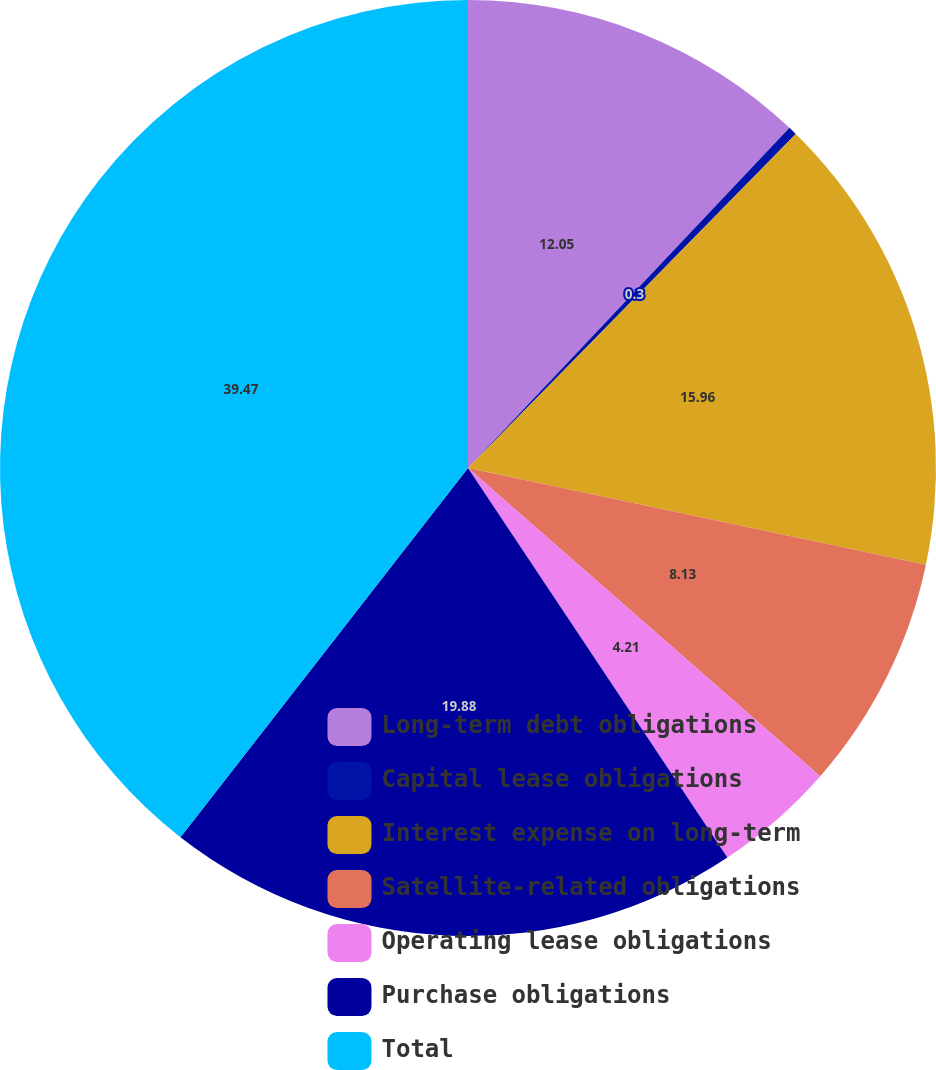Convert chart. <chart><loc_0><loc_0><loc_500><loc_500><pie_chart><fcel>Long-term debt obligations<fcel>Capital lease obligations<fcel>Interest expense on long-term<fcel>Satellite-related obligations<fcel>Operating lease obligations<fcel>Purchase obligations<fcel>Total<nl><fcel>12.05%<fcel>0.3%<fcel>15.96%<fcel>8.13%<fcel>4.21%<fcel>19.88%<fcel>39.47%<nl></chart> 